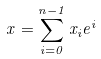<formula> <loc_0><loc_0><loc_500><loc_500>x = \sum _ { i = 0 } ^ { n - 1 } x _ { i } e ^ { i }</formula> 